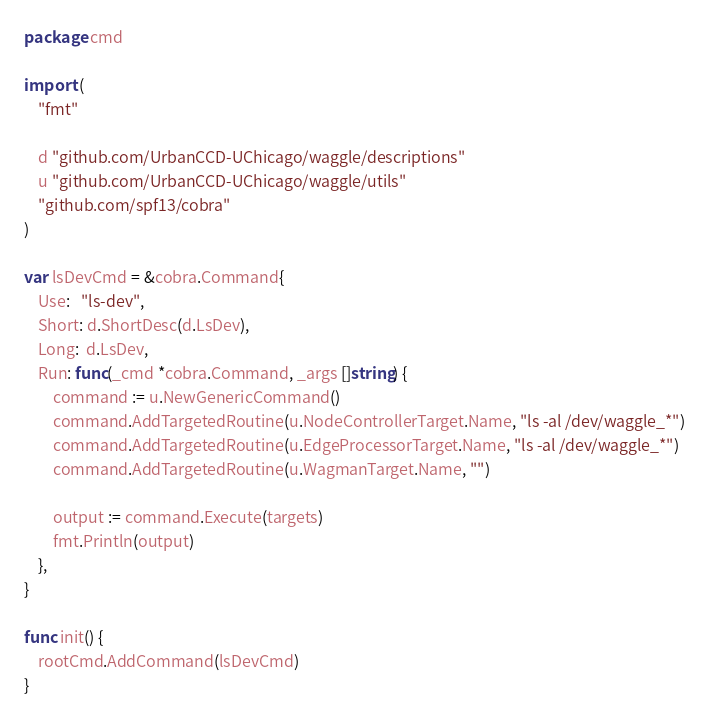<code> <loc_0><loc_0><loc_500><loc_500><_Go_>package cmd

import (
	"fmt"

	d "github.com/UrbanCCD-UChicago/waggle/descriptions"
	u "github.com/UrbanCCD-UChicago/waggle/utils"
	"github.com/spf13/cobra"
)

var lsDevCmd = &cobra.Command{
	Use:   "ls-dev",
	Short: d.ShortDesc(d.LsDev),
	Long:  d.LsDev,
	Run: func(_cmd *cobra.Command, _args []string) {
		command := u.NewGenericCommand()
		command.AddTargetedRoutine(u.NodeControllerTarget.Name, "ls -al /dev/waggle_*")
		command.AddTargetedRoutine(u.EdgeProcessorTarget.Name, "ls -al /dev/waggle_*")
		command.AddTargetedRoutine(u.WagmanTarget.Name, "")

		output := command.Execute(targets)
		fmt.Println(output)
	},
}

func init() {
	rootCmd.AddCommand(lsDevCmd)
}
</code> 